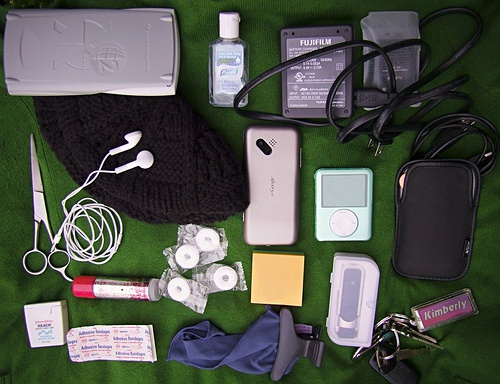Describe the objects in this image and their specific colors. I can see cell phone in black, lightgray, and darkgray tones, bottle in black, lavender, darkgray, and gray tones, and scissors in black, lavender, darkgreen, and darkgray tones in this image. 